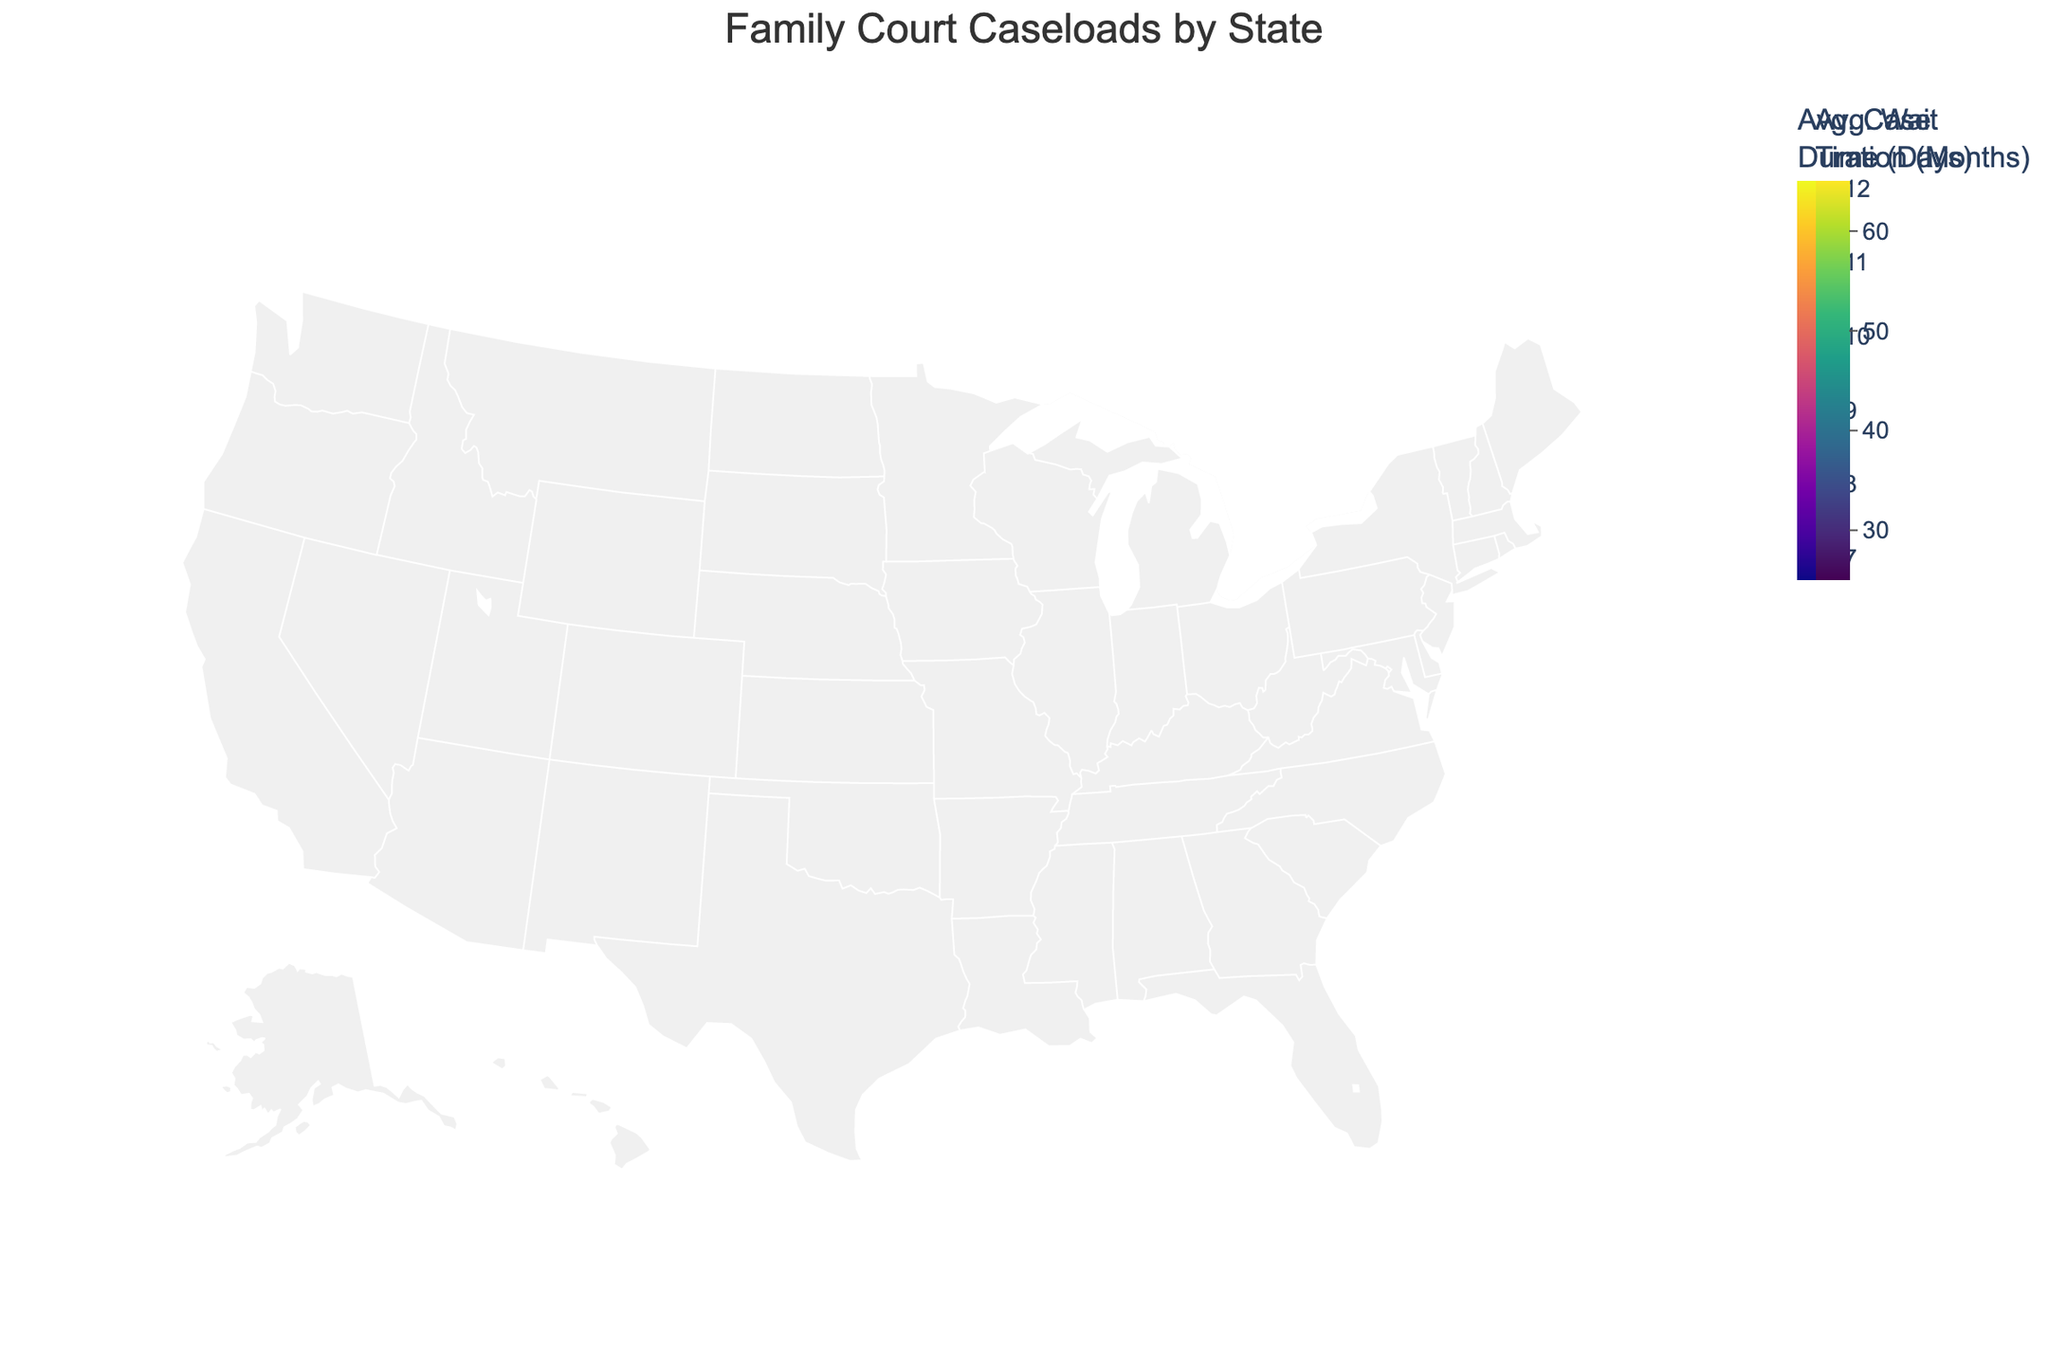How many states have an average wait time of more than 50 days? From the color scale in the figure, we can identify the states with an average wait time of more than 50 days. These states are Massachusetts, New Jersey, Washington, New York, and Illinois.
Answer: 5 Which state has the highest average case duration? By examining the color of the bubbles, we can see that Massachusetts has the highest average case duration of 12.1 months as indicated by the color scale.
Answer: Massachusetts What is the total caseload for Texas? By hovering over the Texas bubble, we can see the total caseload information in the tooltip, which shows that Texas has a total caseload of 10,800.
Answer: 10,800 Compare the average wait times between California and Ohio. Which state has a lower average wait time? By comparing the color intensity of California and Ohio on the map, we see that Ohio (25 days) has a lighter color indicating a lower average wait time compared to California (45 days).
Answer: Ohio Which state has the smallest total caseload and what is its average case duration? By looking at the smallest bubble, we identify Wisconsin as the state with the least total caseload (1,900). The tooltip shows its average case duration is 8.0 months.
Answer: Wisconsin, 8.0 months What is the difference in average wait time between Pennsylvania and Virginia? From the color scale, Pennsylvania has an average wait time of 40 days and Virginia has an average wait time of 42 days. The difference is 42 - 40 = 2 days.
Answer: 2 days Identify the state with both the least average wait time and its corresponding average case duration. By identifying the states with the lightest colors, we see that Ohio has the least average wait time of 25 days. The tooltip reveals its average case duration of 6.8 months.
Answer: Ohio, 6.8 months What is the range of total caseloads in all the states shown on the map? From the bubble sizes, the highest total caseload is in California (12,500) and the smallest is in Wisconsin (1,900). The range is 12,500 - 1,900 = 10,600.
Answer: 10,600 Which states have an average wait time between 30 and 40 days? From the color scale located between 30 and 40 days, the states are Texas, Georgia, Florida, Indiana, and Arizona.
Answer: Texas, Georgia, Florida, Indiana, and Arizona 